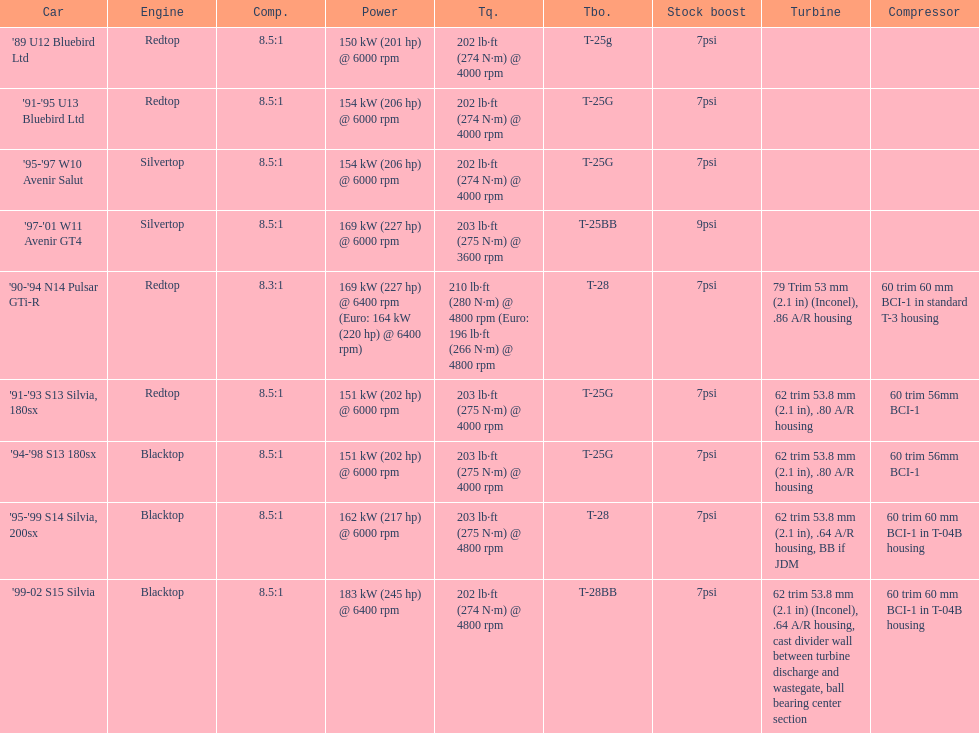Which engine(s) has the least amount of power? Redtop. 